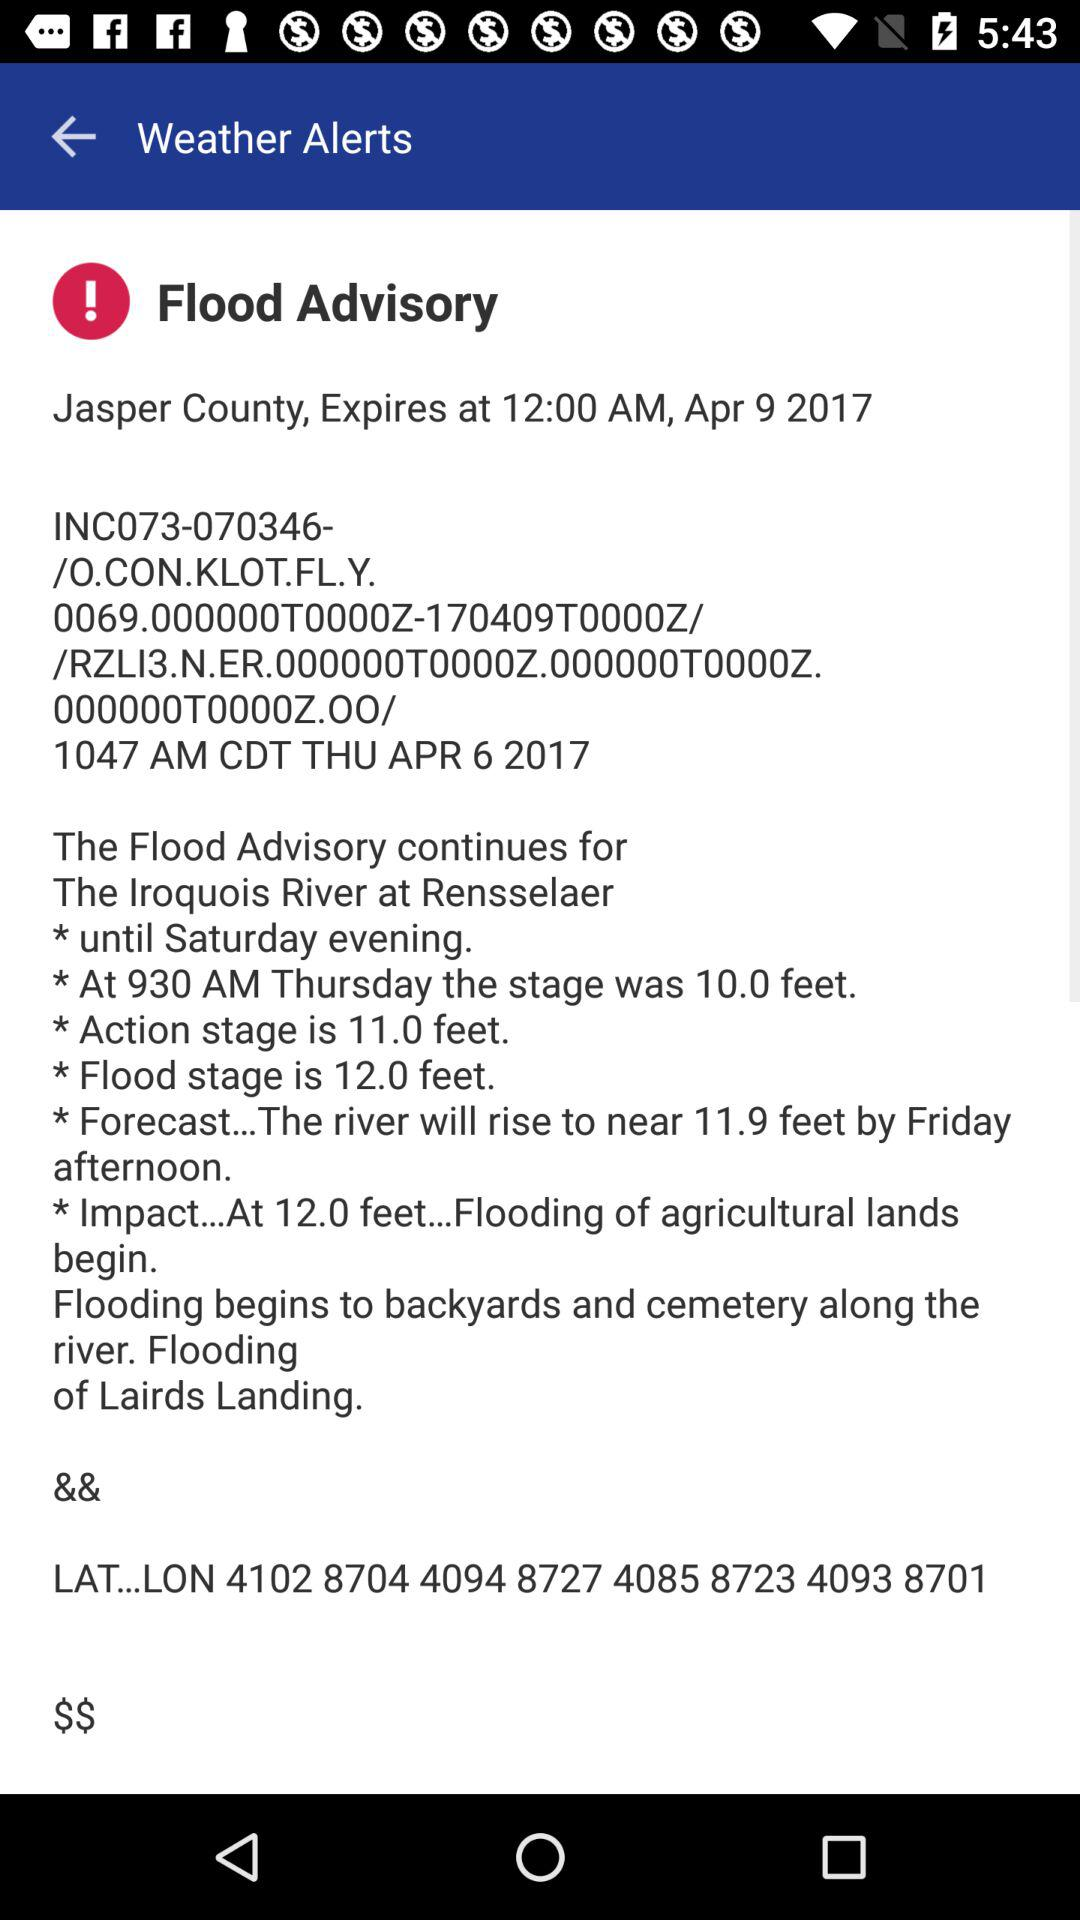What's the stage height at 9:30 AM Thursday? At 9:30 AM Thursday, the stage height was 10.0 feet. 